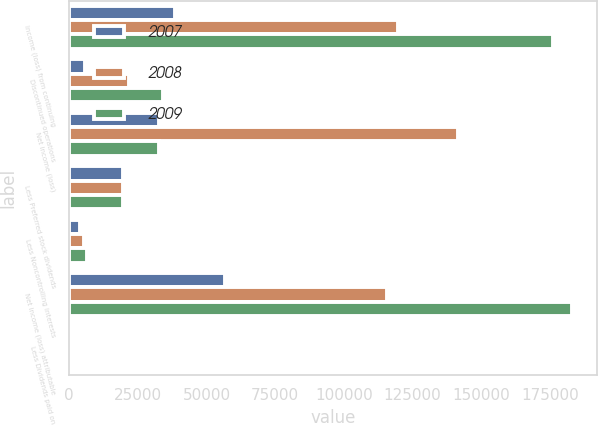<chart> <loc_0><loc_0><loc_500><loc_500><stacked_bar_chart><ecel><fcel>Income (loss) from continuing<fcel>Discontinued operations<fcel>Net income (loss)<fcel>Less Preferred stock dividends<fcel>Less Noncontrolling interests<fcel>Net income (loss) attributable<fcel>Less Dividends paid on<nl><fcel>2007<fcel>38639<fcel>5896<fcel>32743<fcel>19675<fcel>3961<fcel>56867<fcel>488<nl><fcel>2008<fcel>119570<fcel>21951<fcel>141521<fcel>19675<fcel>5333<fcel>115780<fcel>733<nl><fcel>2009<fcel>176013<fcel>34003<fcel>32743<fcel>19675<fcel>6365<fcel>183134<fcel>842<nl></chart> 